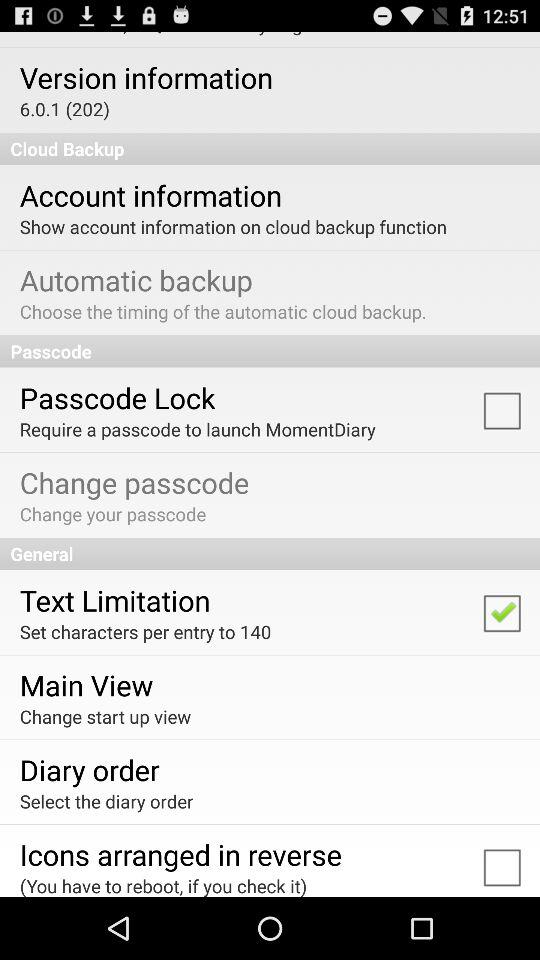How many characters per entry are set? There are 140 characters set per entry. 